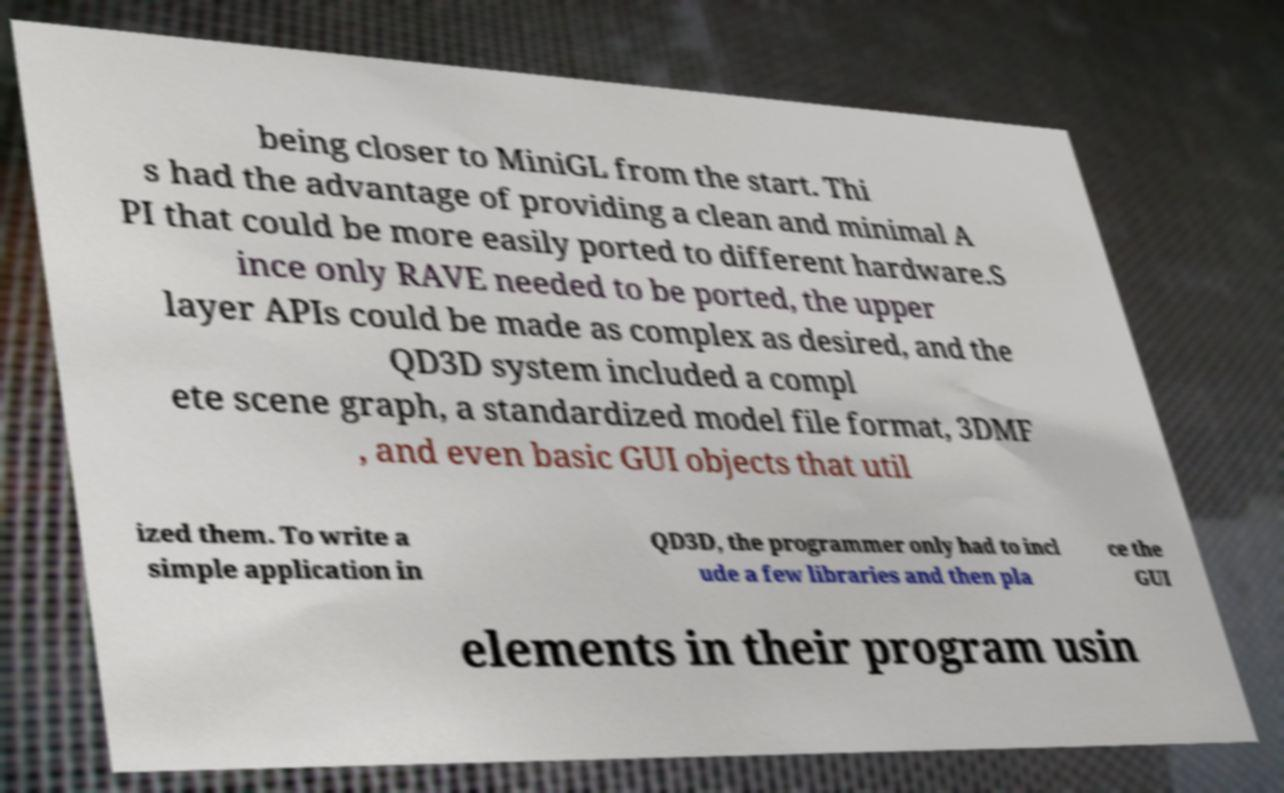Can you accurately transcribe the text from the provided image for me? being closer to MiniGL from the start. Thi s had the advantage of providing a clean and minimal A PI that could be more easily ported to different hardware.S ince only RAVE needed to be ported, the upper layer APIs could be made as complex as desired, and the QD3D system included a compl ete scene graph, a standardized model file format, 3DMF , and even basic GUI objects that util ized them. To write a simple application in QD3D, the programmer only had to incl ude a few libraries and then pla ce the GUI elements in their program usin 